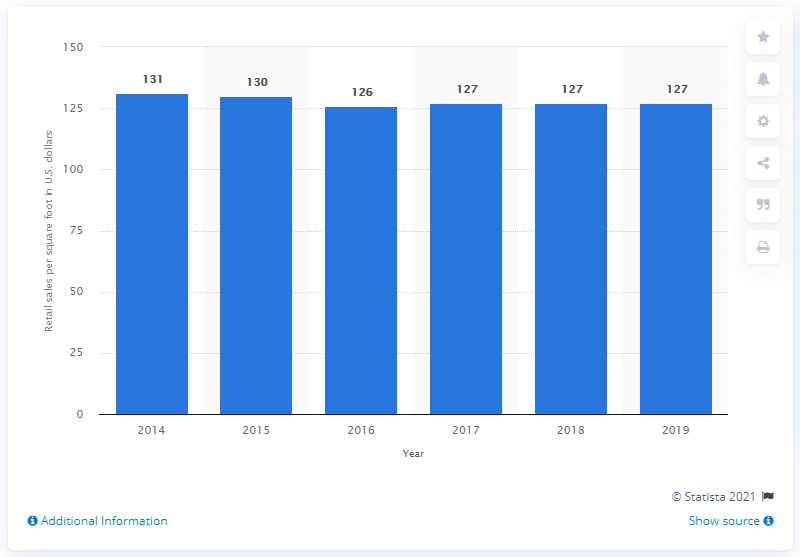List a handful of essential elements in this visual. In 2019, Dillard's global retail sales per square foot in dollars was $127. 